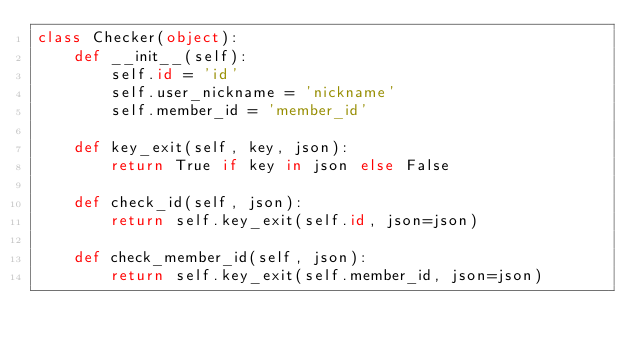Convert code to text. <code><loc_0><loc_0><loc_500><loc_500><_Python_>class Checker(object):
    def __init__(self):
        self.id = 'id'
        self.user_nickname = 'nickname'
        self.member_id = 'member_id'

    def key_exit(self, key, json):
        return True if key in json else False

    def check_id(self, json):
        return self.key_exit(self.id, json=json)

    def check_member_id(self, json):
        return self.key_exit(self.member_id, json=json)
</code> 